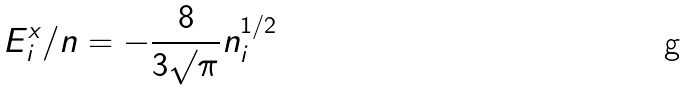Convert formula to latex. <formula><loc_0><loc_0><loc_500><loc_500>E _ { i } ^ { x } / n = - \frac { 8 } { 3 \surd { \pi } } n _ { i } ^ { 1 / 2 }</formula> 